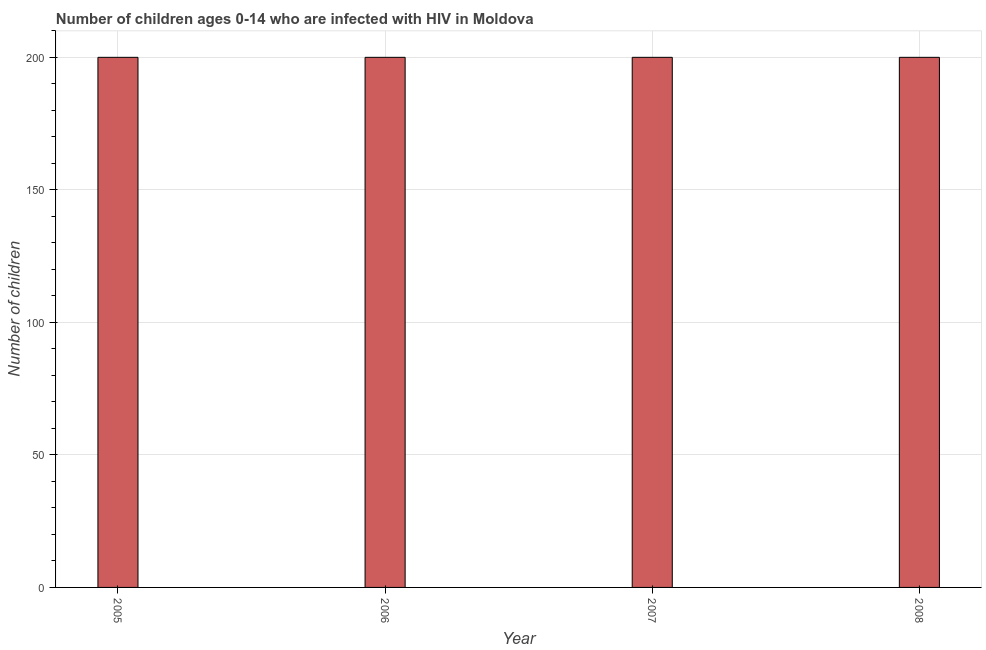What is the title of the graph?
Ensure brevity in your answer.  Number of children ages 0-14 who are infected with HIV in Moldova. What is the label or title of the Y-axis?
Offer a very short reply. Number of children. Across all years, what is the minimum number of children living with hiv?
Offer a terse response. 200. In which year was the number of children living with hiv maximum?
Your response must be concise. 2005. In which year was the number of children living with hiv minimum?
Make the answer very short. 2005. What is the sum of the number of children living with hiv?
Make the answer very short. 800. What is the average number of children living with hiv per year?
Make the answer very short. 200. In how many years, is the number of children living with hiv greater than 130 ?
Your answer should be very brief. 4. Is the number of children living with hiv in 2005 less than that in 2007?
Make the answer very short. No. Is the difference between the number of children living with hiv in 2005 and 2007 greater than the difference between any two years?
Your response must be concise. Yes. How many bars are there?
Offer a very short reply. 4. What is the difference between two consecutive major ticks on the Y-axis?
Offer a very short reply. 50. What is the Number of children in 2005?
Your response must be concise. 200. What is the Number of children in 2006?
Offer a terse response. 200. What is the Number of children of 2008?
Provide a succinct answer. 200. What is the difference between the Number of children in 2006 and 2007?
Keep it short and to the point. 0. What is the ratio of the Number of children in 2005 to that in 2006?
Your response must be concise. 1. What is the ratio of the Number of children in 2005 to that in 2007?
Make the answer very short. 1. What is the ratio of the Number of children in 2005 to that in 2008?
Offer a terse response. 1. What is the ratio of the Number of children in 2006 to that in 2008?
Your answer should be very brief. 1. 